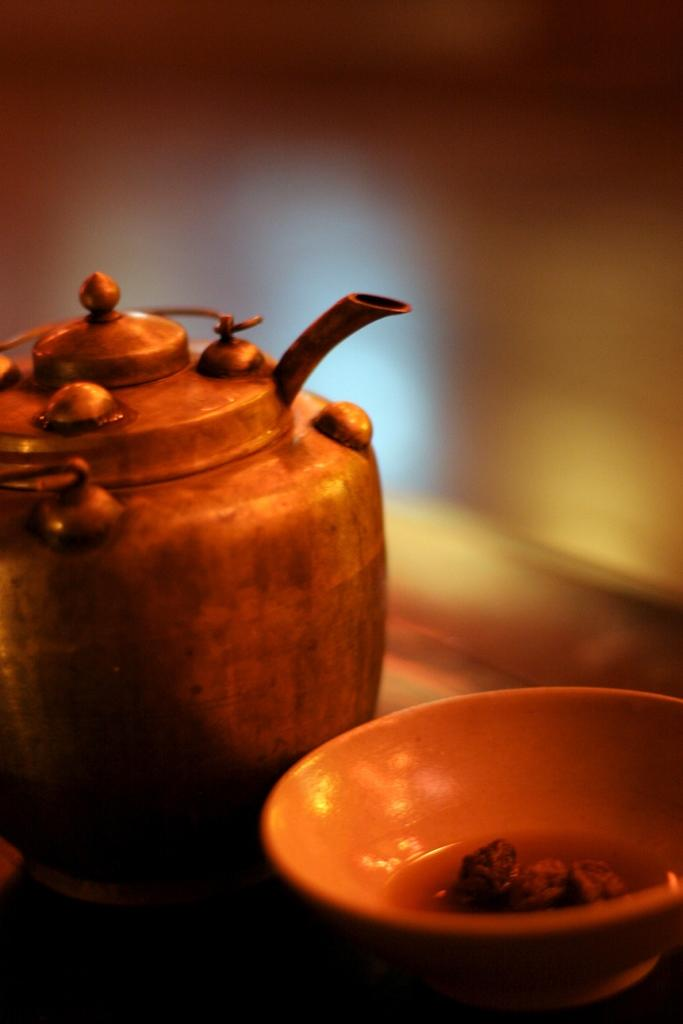What is the main object in the image? There is a teapot in the image. What color is the teapot? The teapot is brown in color. Is there another object in the image that matches the color of the teapot? Yes, there is a bowl in the image, and it is also brown in color. Can you describe the background of the image? The background of the image is blurred. What type of apparatus is being used to test the theory in the image? There is no apparatus or theory present in the image; it only features a brown teapot and a brown bowl. 